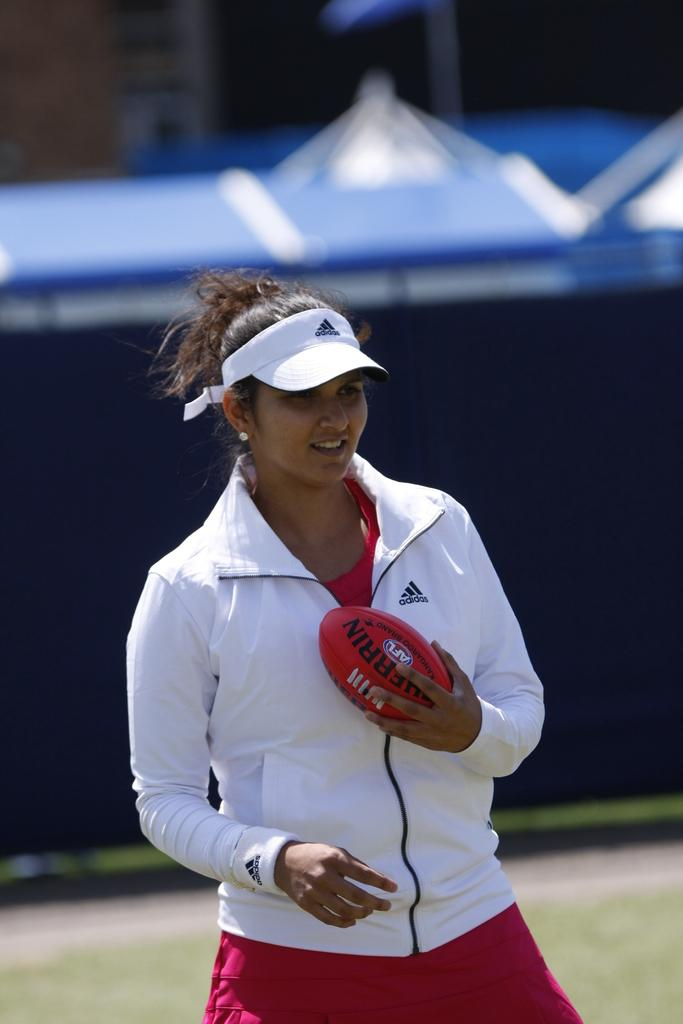Who is the main subject in the picture? There is a woman in the picture. What is the woman wearing? The woman is wearing a white jacket and a white cap on her head. What is the woman holding in her hand? The woman is carrying a rugby ball in her hand. What type of suit can be seen hanging on the wall in the image? There is no suit visible in the image; the woman is wearing a white jacket and cap. Can you hear a bell ringing in the image? There is no bell present in the image, and no sound can be heard from a still image. 